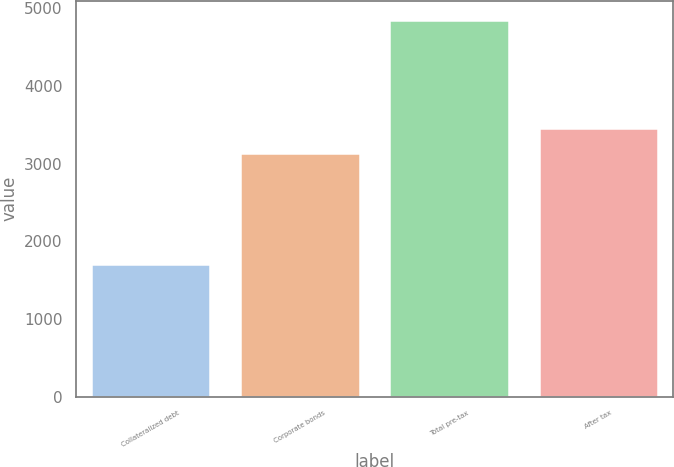Convert chart to OTSL. <chart><loc_0><loc_0><loc_500><loc_500><bar_chart><fcel>Collateralized debt<fcel>Corporate bonds<fcel>Total pre-tax<fcel>After tax<nl><fcel>1712<fcel>3138<fcel>4850<fcel>3451.8<nl></chart> 